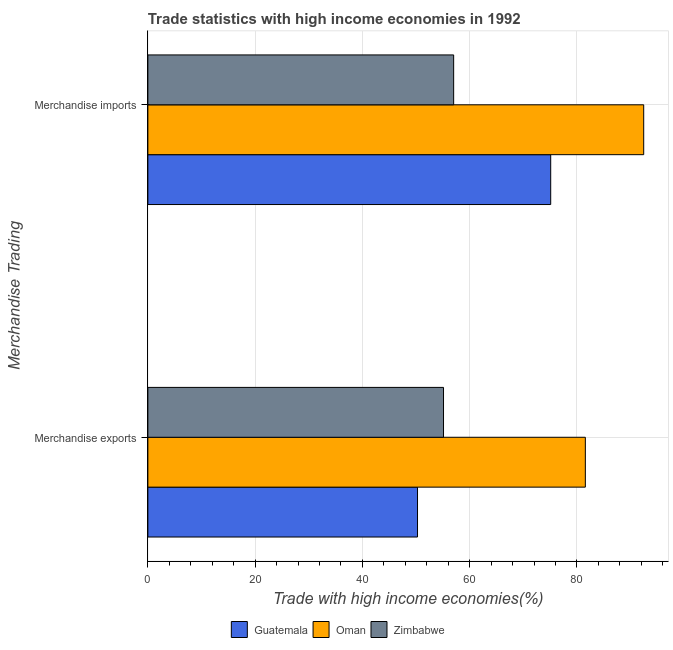How many different coloured bars are there?
Your answer should be very brief. 3. How many groups of bars are there?
Your answer should be compact. 2. Are the number of bars on each tick of the Y-axis equal?
Ensure brevity in your answer.  Yes. What is the merchandise exports in Guatemala?
Provide a succinct answer. 50.28. Across all countries, what is the maximum merchandise imports?
Ensure brevity in your answer.  92.45. Across all countries, what is the minimum merchandise imports?
Your response must be concise. 57.02. In which country was the merchandise imports maximum?
Provide a short and direct response. Oman. In which country was the merchandise exports minimum?
Give a very brief answer. Guatemala. What is the total merchandise exports in the graph?
Offer a very short reply. 186.98. What is the difference between the merchandise imports in Guatemala and that in Oman?
Offer a terse response. -17.34. What is the difference between the merchandise exports in Zimbabwe and the merchandise imports in Oman?
Make the answer very short. -37.33. What is the average merchandise exports per country?
Keep it short and to the point. 62.33. What is the difference between the merchandise exports and merchandise imports in Zimbabwe?
Give a very brief answer. -1.89. In how many countries, is the merchandise imports greater than 48 %?
Provide a short and direct response. 3. What is the ratio of the merchandise imports in Zimbabwe to that in Oman?
Ensure brevity in your answer.  0.62. In how many countries, is the merchandise imports greater than the average merchandise imports taken over all countries?
Make the answer very short. 2. What does the 3rd bar from the top in Merchandise imports represents?
Your answer should be compact. Guatemala. What does the 3rd bar from the bottom in Merchandise imports represents?
Your response must be concise. Zimbabwe. How many bars are there?
Your answer should be compact. 6. What is the difference between two consecutive major ticks on the X-axis?
Keep it short and to the point. 20. Are the values on the major ticks of X-axis written in scientific E-notation?
Your response must be concise. No. Does the graph contain any zero values?
Your answer should be very brief. No. What is the title of the graph?
Ensure brevity in your answer.  Trade statistics with high income economies in 1992. What is the label or title of the X-axis?
Make the answer very short. Trade with high income economies(%). What is the label or title of the Y-axis?
Provide a succinct answer. Merchandise Trading. What is the Trade with high income economies(%) in Guatemala in Merchandise exports?
Offer a very short reply. 50.28. What is the Trade with high income economies(%) in Oman in Merchandise exports?
Offer a terse response. 81.57. What is the Trade with high income economies(%) of Zimbabwe in Merchandise exports?
Give a very brief answer. 55.13. What is the Trade with high income economies(%) in Guatemala in Merchandise imports?
Your answer should be compact. 75.11. What is the Trade with high income economies(%) of Oman in Merchandise imports?
Make the answer very short. 92.45. What is the Trade with high income economies(%) in Zimbabwe in Merchandise imports?
Offer a terse response. 57.02. Across all Merchandise Trading, what is the maximum Trade with high income economies(%) in Guatemala?
Offer a terse response. 75.11. Across all Merchandise Trading, what is the maximum Trade with high income economies(%) in Oman?
Offer a terse response. 92.45. Across all Merchandise Trading, what is the maximum Trade with high income economies(%) of Zimbabwe?
Keep it short and to the point. 57.02. Across all Merchandise Trading, what is the minimum Trade with high income economies(%) in Guatemala?
Keep it short and to the point. 50.28. Across all Merchandise Trading, what is the minimum Trade with high income economies(%) in Oman?
Provide a succinct answer. 81.57. Across all Merchandise Trading, what is the minimum Trade with high income economies(%) of Zimbabwe?
Keep it short and to the point. 55.13. What is the total Trade with high income economies(%) of Guatemala in the graph?
Ensure brevity in your answer.  125.39. What is the total Trade with high income economies(%) of Oman in the graph?
Provide a succinct answer. 174.03. What is the total Trade with high income economies(%) in Zimbabwe in the graph?
Keep it short and to the point. 112.14. What is the difference between the Trade with high income economies(%) in Guatemala in Merchandise exports and that in Merchandise imports?
Your answer should be very brief. -24.83. What is the difference between the Trade with high income economies(%) in Oman in Merchandise exports and that in Merchandise imports?
Keep it short and to the point. -10.88. What is the difference between the Trade with high income economies(%) in Zimbabwe in Merchandise exports and that in Merchandise imports?
Your response must be concise. -1.89. What is the difference between the Trade with high income economies(%) in Guatemala in Merchandise exports and the Trade with high income economies(%) in Oman in Merchandise imports?
Keep it short and to the point. -42.18. What is the difference between the Trade with high income economies(%) in Guatemala in Merchandise exports and the Trade with high income economies(%) in Zimbabwe in Merchandise imports?
Your answer should be very brief. -6.74. What is the difference between the Trade with high income economies(%) of Oman in Merchandise exports and the Trade with high income economies(%) of Zimbabwe in Merchandise imports?
Your answer should be very brief. 24.56. What is the average Trade with high income economies(%) of Guatemala per Merchandise Trading?
Offer a very short reply. 62.7. What is the average Trade with high income economies(%) of Oman per Merchandise Trading?
Offer a terse response. 87.01. What is the average Trade with high income economies(%) of Zimbabwe per Merchandise Trading?
Your response must be concise. 56.07. What is the difference between the Trade with high income economies(%) of Guatemala and Trade with high income economies(%) of Oman in Merchandise exports?
Offer a very short reply. -31.3. What is the difference between the Trade with high income economies(%) in Guatemala and Trade with high income economies(%) in Zimbabwe in Merchandise exports?
Provide a short and direct response. -4.85. What is the difference between the Trade with high income economies(%) of Oman and Trade with high income economies(%) of Zimbabwe in Merchandise exports?
Provide a short and direct response. 26.45. What is the difference between the Trade with high income economies(%) in Guatemala and Trade with high income economies(%) in Oman in Merchandise imports?
Make the answer very short. -17.34. What is the difference between the Trade with high income economies(%) of Guatemala and Trade with high income economies(%) of Zimbabwe in Merchandise imports?
Offer a terse response. 18.09. What is the difference between the Trade with high income economies(%) of Oman and Trade with high income economies(%) of Zimbabwe in Merchandise imports?
Make the answer very short. 35.44. What is the ratio of the Trade with high income economies(%) of Guatemala in Merchandise exports to that in Merchandise imports?
Offer a terse response. 0.67. What is the ratio of the Trade with high income economies(%) in Oman in Merchandise exports to that in Merchandise imports?
Your answer should be very brief. 0.88. What is the ratio of the Trade with high income economies(%) in Zimbabwe in Merchandise exports to that in Merchandise imports?
Make the answer very short. 0.97. What is the difference between the highest and the second highest Trade with high income economies(%) in Guatemala?
Provide a short and direct response. 24.83. What is the difference between the highest and the second highest Trade with high income economies(%) in Oman?
Ensure brevity in your answer.  10.88. What is the difference between the highest and the second highest Trade with high income economies(%) in Zimbabwe?
Give a very brief answer. 1.89. What is the difference between the highest and the lowest Trade with high income economies(%) in Guatemala?
Provide a short and direct response. 24.83. What is the difference between the highest and the lowest Trade with high income economies(%) of Oman?
Provide a short and direct response. 10.88. What is the difference between the highest and the lowest Trade with high income economies(%) of Zimbabwe?
Give a very brief answer. 1.89. 